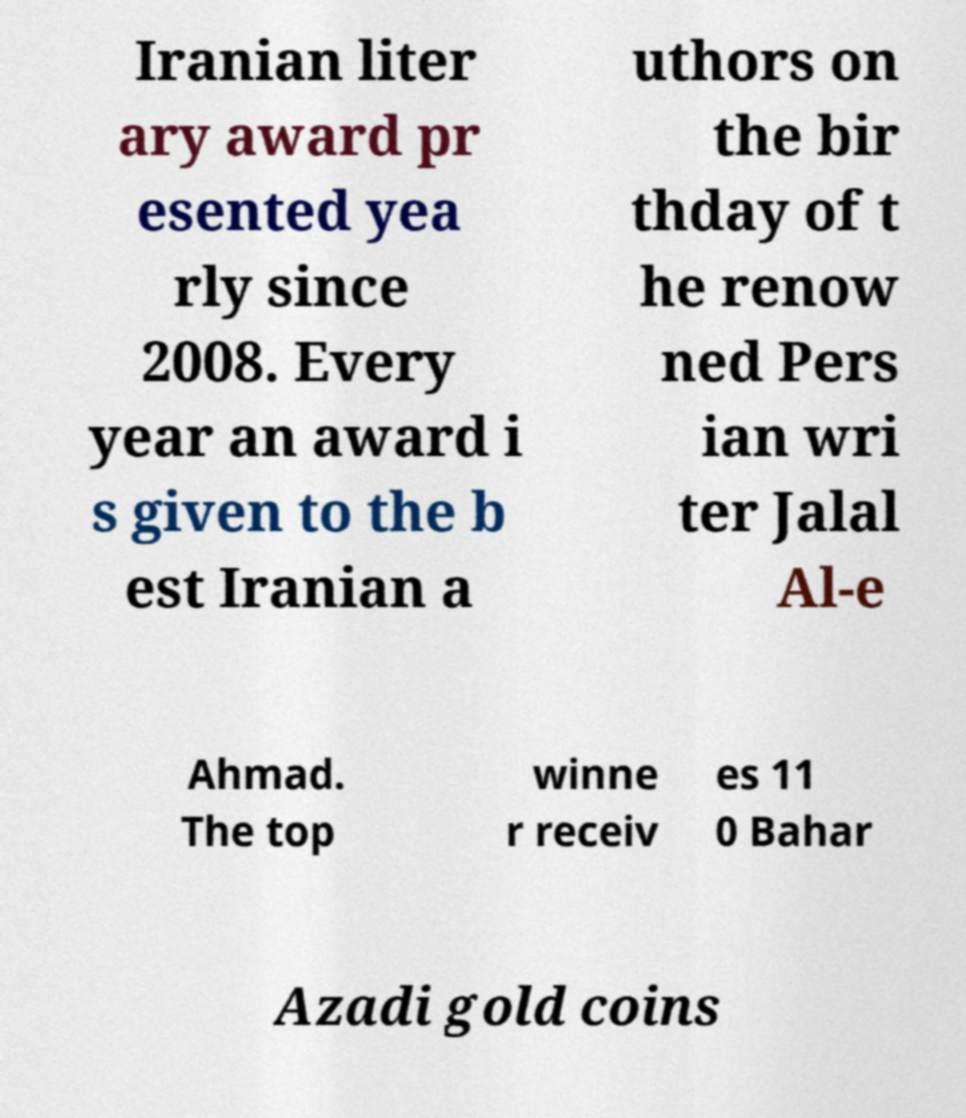Can you accurately transcribe the text from the provided image for me? Iranian liter ary award pr esented yea rly since 2008. Every year an award i s given to the b est Iranian a uthors on the bir thday of t he renow ned Pers ian wri ter Jalal Al-e Ahmad. The top winne r receiv es 11 0 Bahar Azadi gold coins 